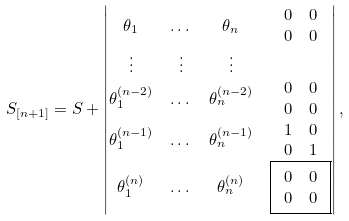Convert formula to latex. <formula><loc_0><loc_0><loc_500><loc_500>S _ { [ n + 1 ] } & = S + \begin{vmatrix} \theta _ { 1 } & \dots & \theta _ { n } & \begin{array} { c c } 0 & 0 \\ 0 & 0 \end{array} \\ \vdots & \vdots & \vdots \\ \theta _ { 1 } ^ { ( n - 2 ) } & \dots & \theta _ { n } ^ { ( n - 2 ) } & \begin{array} { c c } 0 & 0 \\ 0 & 0 \end{array} \\ \theta _ { 1 } ^ { ( n - 1 ) } & \dots & \theta _ { n } ^ { ( n - 1 ) } & \begin{array} { c c } 1 & 0 \\ 0 & 1 \end{array} \\ \theta _ { 1 } ^ { ( n ) } & \dots & \theta _ { n } ^ { ( n ) } & \boxed { \begin{array} { c c } 0 & 0 \\ 0 & 0 \end{array} } \end{vmatrix} ,</formula> 